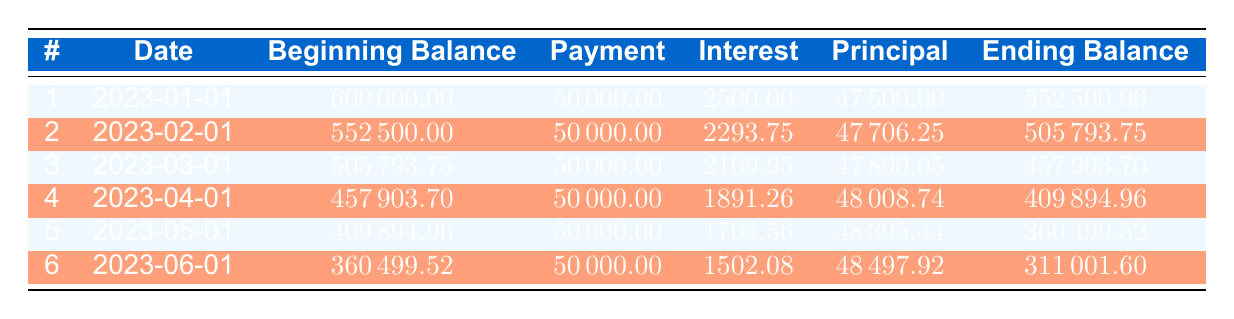what is the monthly lease payment for the facility? The table specifies that the monthly lease payment is listed directly in the lease_details section, which states it is 50,000.
Answer: 50000 how much was the beginning balance for the first payment? The beginning balance for the first payment is straightforwardly shown in the first row of the table as 600,000.
Answer: 600000 which payment number had the highest principal payment? The highest principal payment can be found by comparing the principal payment amounts from all payment rows, which shows that payment number 5 has the highest principal payment at 48,395.44.
Answer: 5 what is the total interest paid in the first six months? To find the total interest paid, we add the interest payments for all six months: 2500 + 2293.75 + 2109.95 + 1891.26 + 1704.56 + 1502.08 = 11701.60.
Answer: 11701.60 is the ending balance after the second payment less than after the first payment? The ending balance after the second payment is shown as 505,793.75, while after the first payment it is 552,500. Since 505,793.75 is less than 552,500, the statement is true.
Answer: Yes what is the average monthly interest payment over the first six payments? To calculate the average monthly interest payment, we sum the interest payments for the six payments (2500 + 2293.75 + 2109.95 + 1891.26 + 1704.56 + 1502.08 = 11701.60) and divide by 6. Thus, the average interest payment equals 11701.60 / 6 = 1950.27.
Answer: 1950.27 what is the difference in ending balance between the first and the sixth payment? The ending balance after the first payment is 552,500 and after the sixth payment is 311,001.60. The difference can be calculated as 552,500 - 311,001.60 = 241,498.40.
Answer: 241498.40 does the principal payment increase, decrease, or stay the same over the first six payments? By reviewing the principal payments in the table, we see the values: 47,500; 47,706.25; 47,890.05; 48,008.74; 48,395.44; and 48,497.92. The values consistently increase from the first payment to the last payment.
Answer: Increase how much of the monthly payment goes towards interest in the sixth month? According to the table, the interest payment for the sixth month is specifically stated as 1,502.08. Therefore, this is the amount of the monthly payment going towards interest.
Answer: 1502.08 